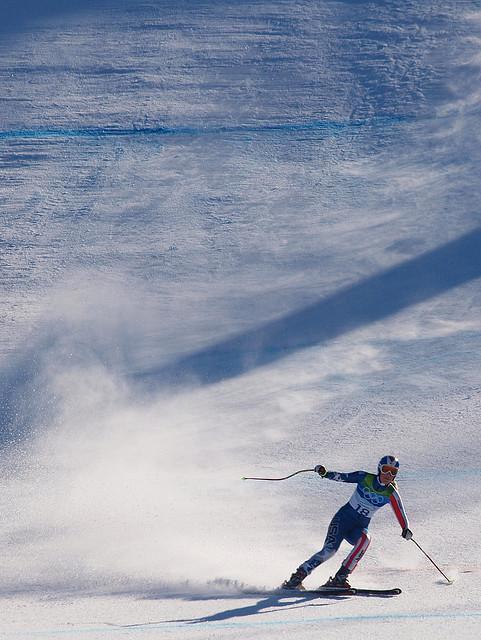How many people are shown?
Give a very brief answer. 1. How many buses are there?
Give a very brief answer. 0. 